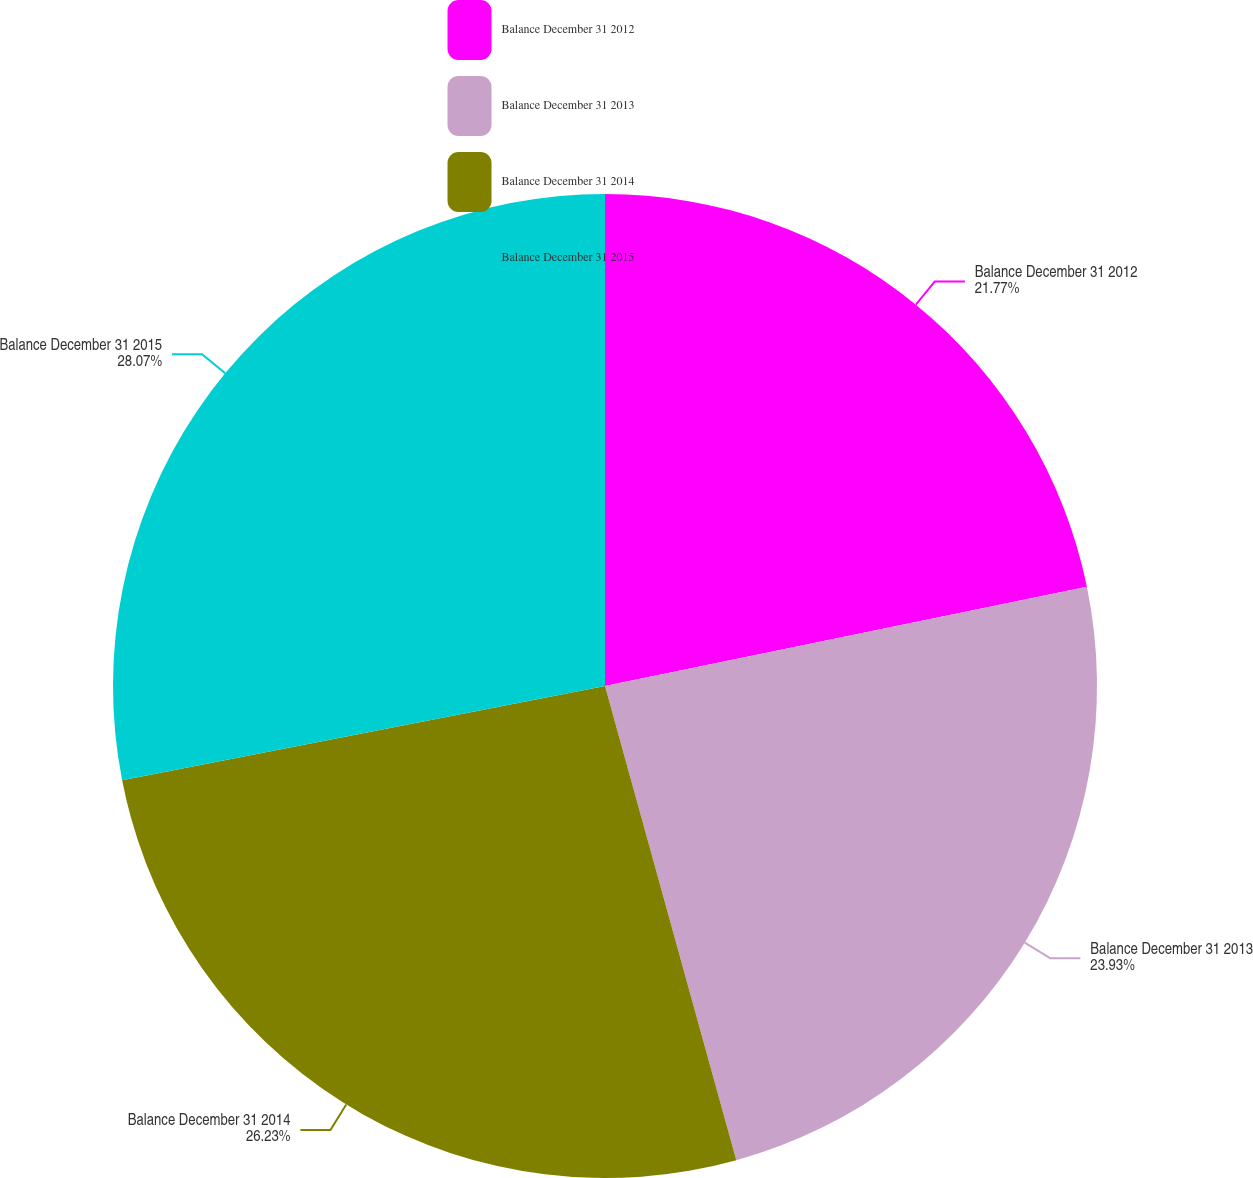<chart> <loc_0><loc_0><loc_500><loc_500><pie_chart><fcel>Balance December 31 2012<fcel>Balance December 31 2013<fcel>Balance December 31 2014<fcel>Balance December 31 2015<nl><fcel>21.77%<fcel>23.93%<fcel>26.23%<fcel>28.07%<nl></chart> 